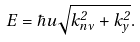Convert formula to latex. <formula><loc_0><loc_0><loc_500><loc_500>E = \hbar { u } \sqrt { k _ { n \nu } ^ { 2 } + k _ { y } ^ { 2 } } .</formula> 